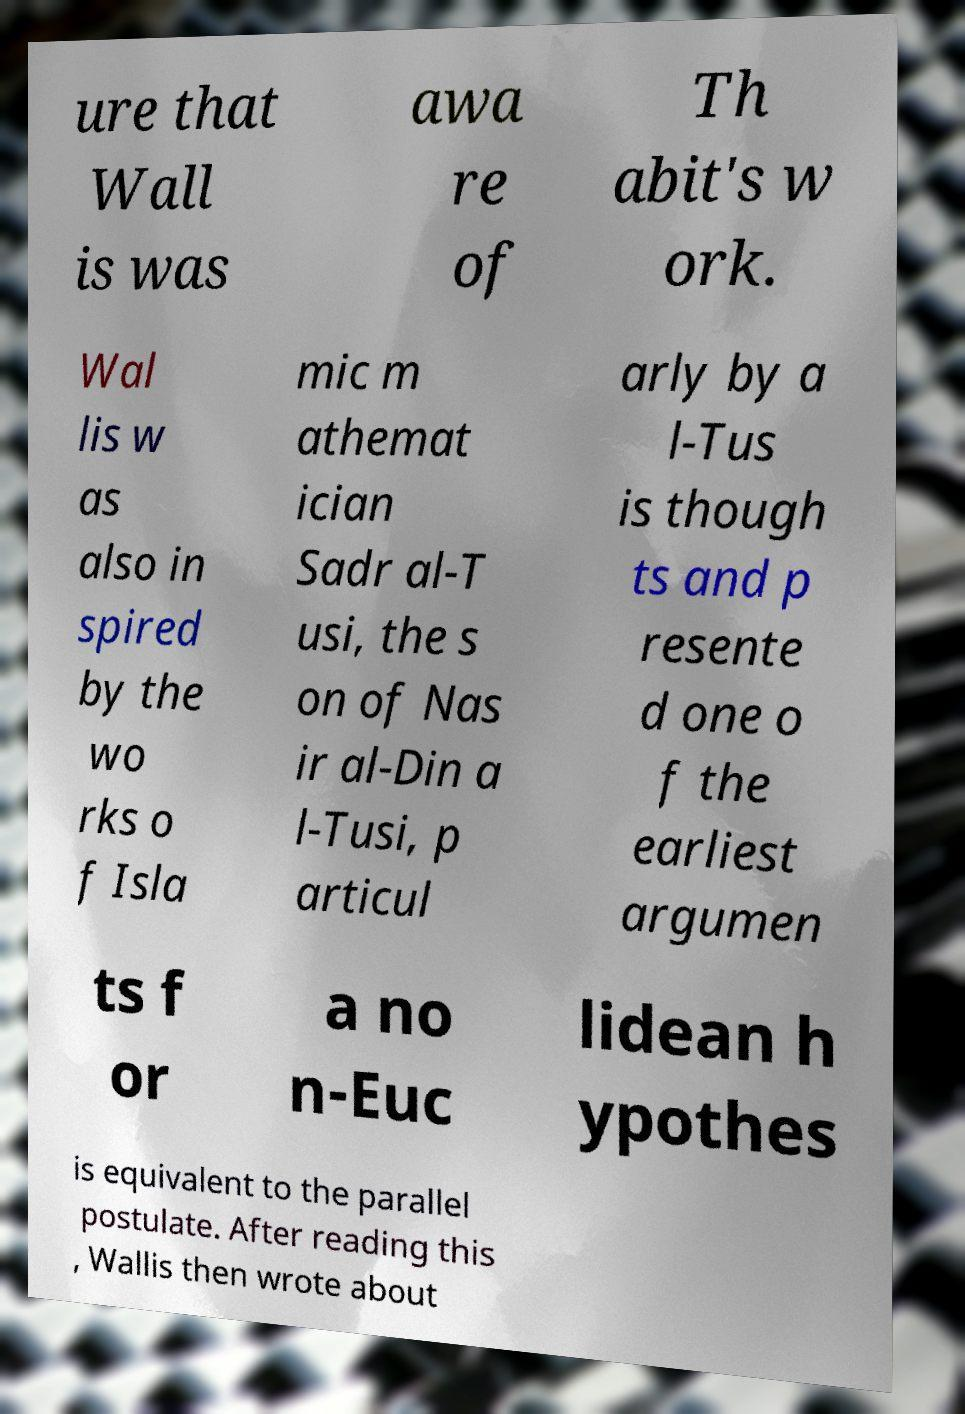I need the written content from this picture converted into text. Can you do that? ure that Wall is was awa re of Th abit's w ork. Wal lis w as also in spired by the wo rks o f Isla mic m athemat ician Sadr al-T usi, the s on of Nas ir al-Din a l-Tusi, p articul arly by a l-Tus is though ts and p resente d one o f the earliest argumen ts f or a no n-Euc lidean h ypothes is equivalent to the parallel postulate. After reading this , Wallis then wrote about 